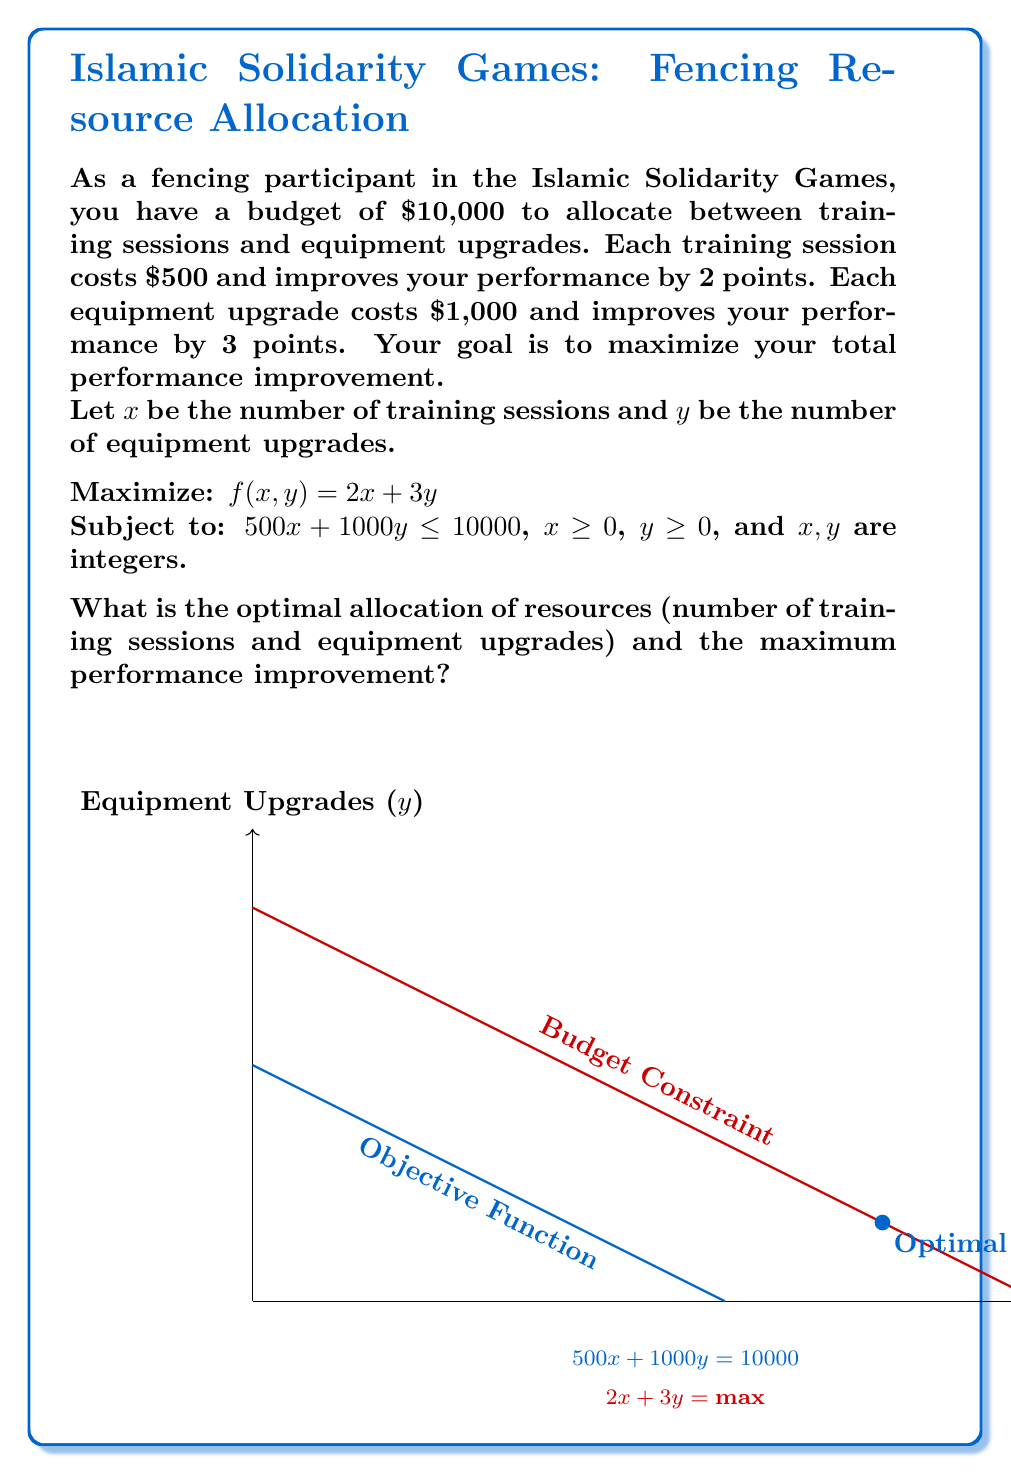Give your solution to this math problem. Let's solve this problem step by step:

1) First, we need to set up the linear programming problem:

   Maximize: $f(x,y) = 2x + 3y$
   Subject to: $500x + 1000y \leq 10000$, $x \geq 0$, $y \geq 0$, and $x,y$ are integers

2) Simplify the constraint:
   $500x + 1000y \leq 10000$
   $x + 2y \leq 20$

3) The optimal solution will be at one of the integer points along this constraint line. Let's list out the possible integer solutions:

   (20, 0), (18, 1), (16, 2), (14, 3), (12, 4), (10, 5), (8, 6), (6, 7), (4, 8), (2, 9), (0, 10)

4) Now, let's calculate the objective function value for each of these points:

   f(20, 0) = 2(20) + 3(0) = 40
   f(18, 1) = 2(18) + 3(1) = 39
   f(16, 2) = 2(16) + 3(2) = 38
   f(14, 3) = 2(14) + 3(3) = 37
   f(12, 4) = 2(12) + 3(4) = 36
   f(10, 5) = 2(10) + 3(5) = 35
   f(8, 6) = 2(8) + 3(6) = 34
   f(6, 7) = 2(6) + 3(7) = 33
   f(4, 8) = 2(4) + 3(8) = 32
   f(2, 9) = 2(2) + 3(9) = 31
   f(0, 10) = 2(0) + 3(10) = 30

5) The maximum value is 40, which occurs at the point (20, 0).

Therefore, the optimal allocation is 20 training sessions and 0 equipment upgrades, resulting in a maximum performance improvement of 40 points.
Answer: 20 training sessions, 0 equipment upgrades; 40 points improvement 